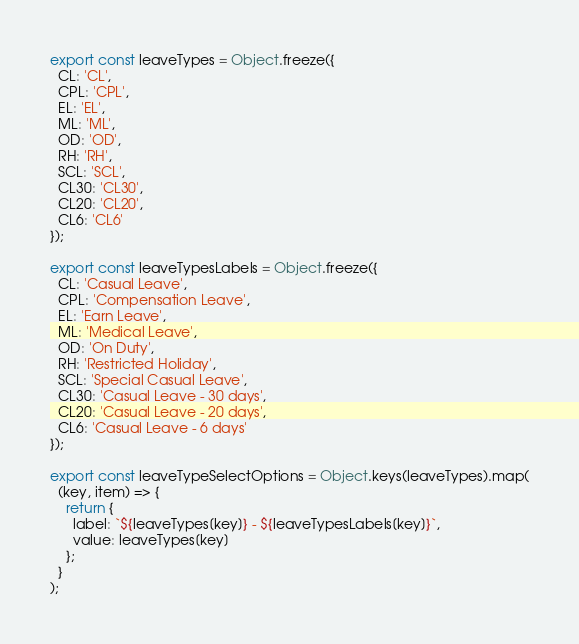<code> <loc_0><loc_0><loc_500><loc_500><_JavaScript_>export const leaveTypes = Object.freeze({
  CL: 'CL',
  CPL: 'CPL',
  EL: 'EL',
  ML: 'ML',
  OD: 'OD',
  RH: 'RH',
  SCL: 'SCL',
  CL30: 'CL30',
  CL20: 'CL20',
  CL6: 'CL6'
});

export const leaveTypesLabels = Object.freeze({
  CL: 'Casual Leave',
  CPL: 'Compensation Leave',
  EL: 'Earn Leave',
  ML: 'Medical Leave',
  OD: 'On Duty',
  RH: 'Restricted Holiday',
  SCL: 'Special Casual Leave',
  CL30: 'Casual Leave - 30 days',
  CL20: 'Casual Leave - 20 days',
  CL6: 'Casual Leave - 6 days'
});

export const leaveTypeSelectOptions = Object.keys(leaveTypes).map(
  (key, item) => {
    return {
      label: `${leaveTypes[key]} - ${leaveTypesLabels[key]}`,
      value: leaveTypes[key]
    };
  }
);
</code> 